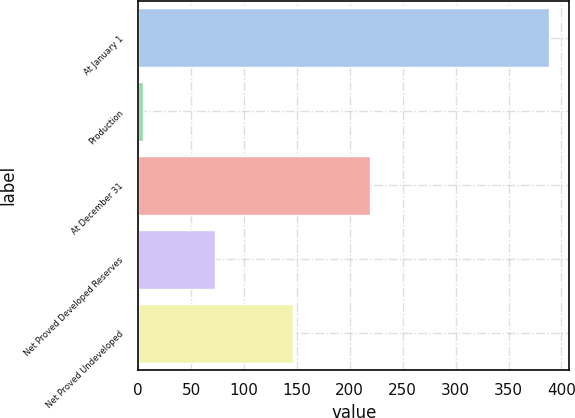Convert chart. <chart><loc_0><loc_0><loc_500><loc_500><bar_chart><fcel>At January 1<fcel>Production<fcel>At December 31<fcel>Net Proved Developed Reserves<fcel>Net Proved Undeveloped<nl><fcel>388<fcel>5<fcel>219<fcel>73<fcel>146<nl></chart> 